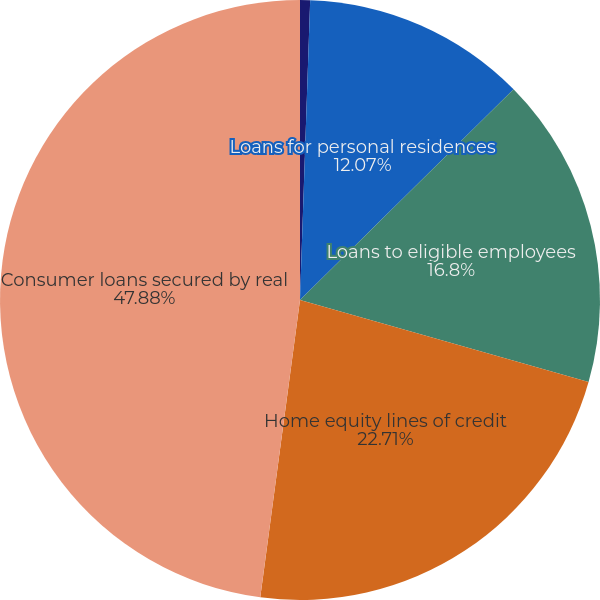Convert chart. <chart><loc_0><loc_0><loc_500><loc_500><pie_chart><fcel>(Dollars in thousands)<fcel>Loans for personal residences<fcel>Loans to eligible employees<fcel>Home equity lines of credit<fcel>Consumer loans secured by real<nl><fcel>0.54%<fcel>12.07%<fcel>16.8%<fcel>22.71%<fcel>47.89%<nl></chart> 